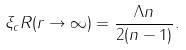<formula> <loc_0><loc_0><loc_500><loc_500>\xi _ { c } R ( r \rightarrow \infty ) = \frac { \Lambda n } { 2 ( n - 1 ) } .</formula> 